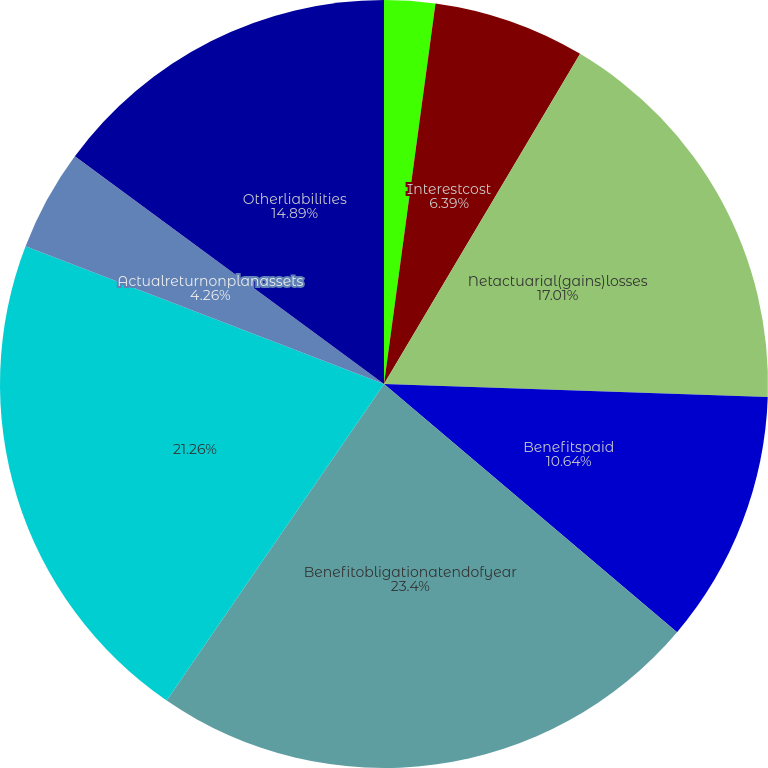<chart> <loc_0><loc_0><loc_500><loc_500><pie_chart><fcel>Servicecost<fcel>Interestcost<fcel>Netactuarial(gains)losses<fcel>Benefitspaid<fcel>Benefitobligationatendofyear<fcel>Unnamed: 5<fcel>Actualreturnonplanassets<fcel>Employercontribution<fcel>Otherliabilities<nl><fcel>2.14%<fcel>6.39%<fcel>17.01%<fcel>10.64%<fcel>23.39%<fcel>21.26%<fcel>4.26%<fcel>0.01%<fcel>14.89%<nl></chart> 